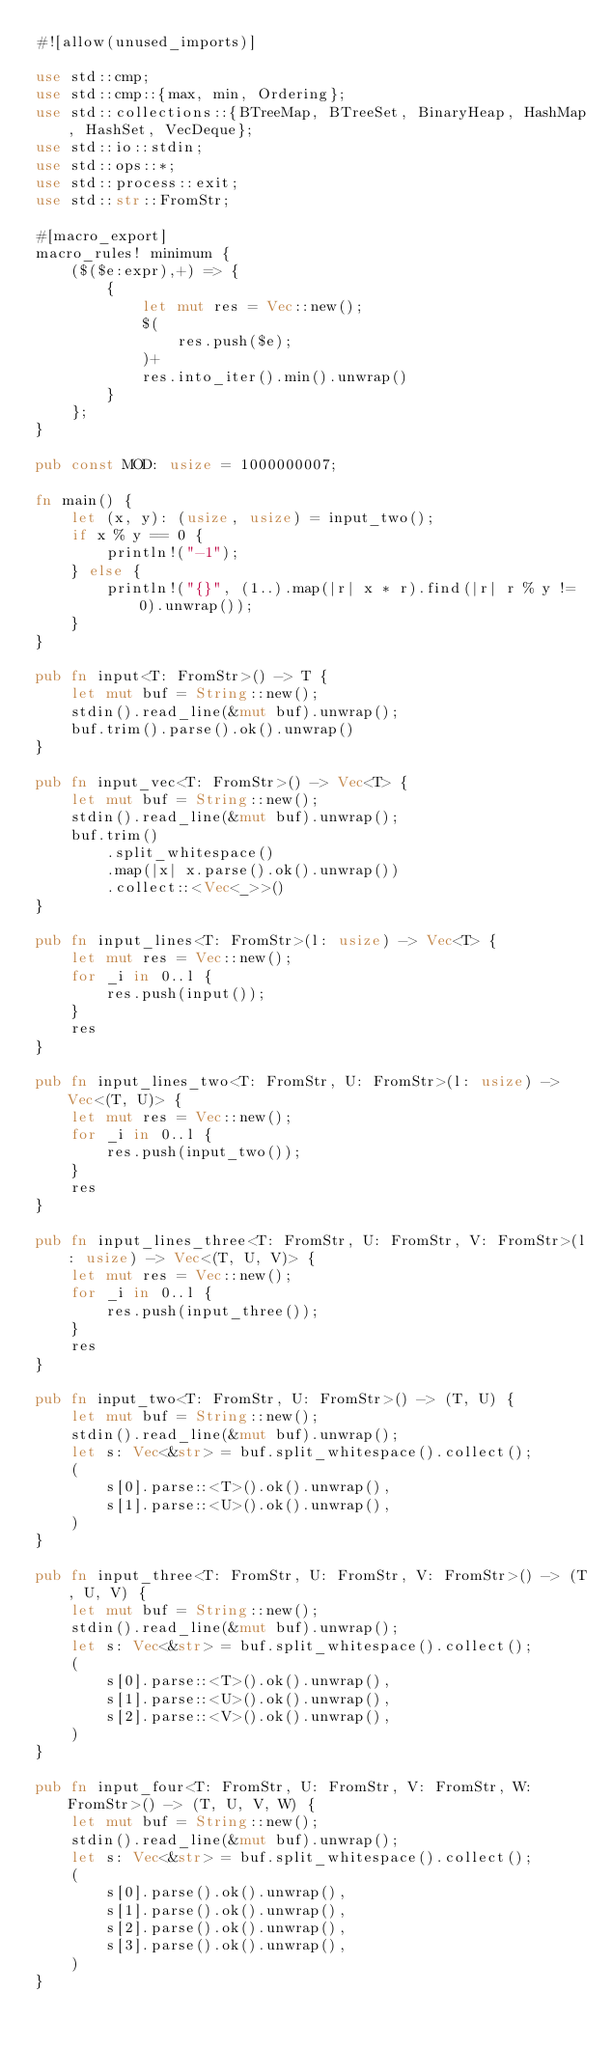Convert code to text. <code><loc_0><loc_0><loc_500><loc_500><_Rust_>#![allow(unused_imports)]

use std::cmp;
use std::cmp::{max, min, Ordering};
use std::collections::{BTreeMap, BTreeSet, BinaryHeap, HashMap, HashSet, VecDeque};
use std::io::stdin;
use std::ops::*;
use std::process::exit;
use std::str::FromStr;

#[macro_export]
macro_rules! minimum {
    ($($e:expr),+) => {
        {
            let mut res = Vec::new();
            $(
                res.push($e);
            )+
            res.into_iter().min().unwrap()
        }
    };
}

pub const MOD: usize = 1000000007;

fn main() {
    let (x, y): (usize, usize) = input_two();
    if x % y == 0 {
        println!("-1");
    } else {
        println!("{}", (1..).map(|r| x * r).find(|r| r % y != 0).unwrap());
    }
}

pub fn input<T: FromStr>() -> T {
    let mut buf = String::new();
    stdin().read_line(&mut buf).unwrap();
    buf.trim().parse().ok().unwrap()
}

pub fn input_vec<T: FromStr>() -> Vec<T> {
    let mut buf = String::new();
    stdin().read_line(&mut buf).unwrap();
    buf.trim()
        .split_whitespace()
        .map(|x| x.parse().ok().unwrap())
        .collect::<Vec<_>>()
}

pub fn input_lines<T: FromStr>(l: usize) -> Vec<T> {
    let mut res = Vec::new();
    for _i in 0..l {
        res.push(input());
    }
    res
}

pub fn input_lines_two<T: FromStr, U: FromStr>(l: usize) -> Vec<(T, U)> {
    let mut res = Vec::new();
    for _i in 0..l {
        res.push(input_two());
    }
    res
}

pub fn input_lines_three<T: FromStr, U: FromStr, V: FromStr>(l: usize) -> Vec<(T, U, V)> {
    let mut res = Vec::new();
    for _i in 0..l {
        res.push(input_three());
    }
    res
}

pub fn input_two<T: FromStr, U: FromStr>() -> (T, U) {
    let mut buf = String::new();
    stdin().read_line(&mut buf).unwrap();
    let s: Vec<&str> = buf.split_whitespace().collect();
    (
        s[0].parse::<T>().ok().unwrap(),
        s[1].parse::<U>().ok().unwrap(),
    )
}

pub fn input_three<T: FromStr, U: FromStr, V: FromStr>() -> (T, U, V) {
    let mut buf = String::new();
    stdin().read_line(&mut buf).unwrap();
    let s: Vec<&str> = buf.split_whitespace().collect();
    (
        s[0].parse::<T>().ok().unwrap(),
        s[1].parse::<U>().ok().unwrap(),
        s[2].parse::<V>().ok().unwrap(),
    )
}

pub fn input_four<T: FromStr, U: FromStr, V: FromStr, W: FromStr>() -> (T, U, V, W) {
    let mut buf = String::new();
    stdin().read_line(&mut buf).unwrap();
    let s: Vec<&str> = buf.split_whitespace().collect();
    (
        s[0].parse().ok().unwrap(),
        s[1].parse().ok().unwrap(),
        s[2].parse().ok().unwrap(),
        s[3].parse().ok().unwrap(),
    )
}
</code> 